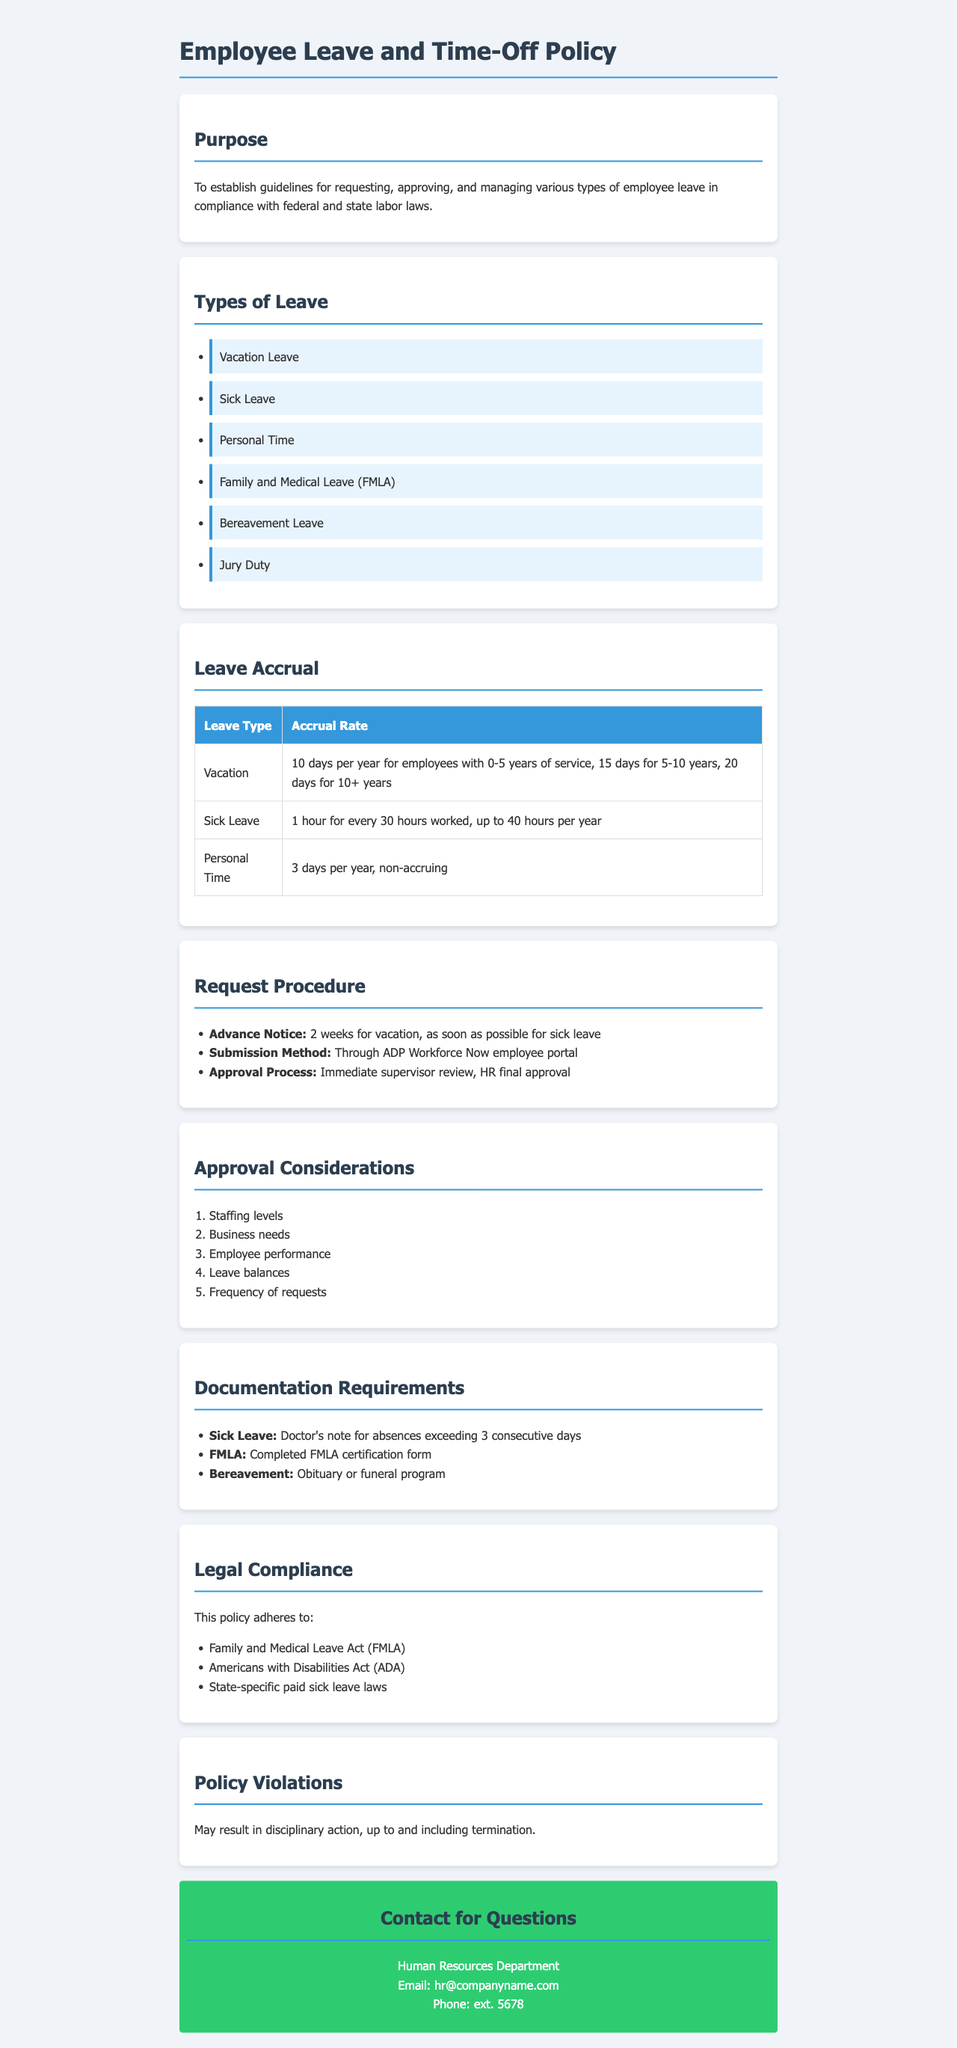What is the purpose of the policy? The purpose of the policy is to establish guidelines for requesting, approving, and managing various types of employee leave in compliance with federal and state labor laws.
Answer: Guidelines for requesting, approving, and managing various types of employee leave in compliance with federal and state labor laws How many days of vacation leave do employees with 6 years of service receive? Employees with 5-10 years of service receive 15 days of vacation leave, and those with 10+ years receive 20 days. Therefore, employees with 6 years are in the 5-10 year category, which is 15 days.
Answer: 15 days What documentation is required for bereavement leave? The required documentation for bereavement leave is specifically stated. It is an obituary or funeral program.
Answer: Obituary or funeral program What is the sick leave accrual rate? The sick leave accrual rate is detailed in the document. It states that employees earn 1 hour of sick leave for every 30 hours worked, up to 40 hours per year.
Answer: 1 hour for every 30 hours worked, up to 40 hours per year Who needs to approve the leave requests? The document specifies that the approval process involves two levels: immediate supervisor review and HR final approval.
Answer: Immediate supervisor review, HR final approval What are the main considerations during leave approval? The approval considerations are listed in the document, focusing on several criteria such as staffing levels and employee performance.
Answer: Staffing levels, business needs, employee performance, leave balances, frequency of requests How many personal time days are available each year? The document outlines that employees receive personal time annually. Specifically, they receive 3 days per year, which is non-accruing.
Answer: 3 days per year What happens if the policy is violated? The document clearly states that violations of the policy may result in disciplinary action.
Answer: Disciplinary action, up to and including termination What is the contact email for the Human Resources Department? The document provides the contact information for HR, specifically listing the email address for inquiries.
Answer: hr@companyname.com 